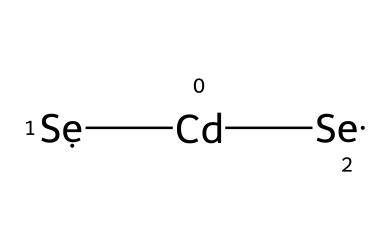What elements are present in this quantum dot? The chemical structure features Cadmium (Cd) and Selenium (Se), which can be identified by their symbols in the SMILES representation.
Answer: Cadmium, Selenium How many atoms are in the quantum dot? The SMILES representation indicates there are four atoms: one Cadmium and three Selenium atoms. Count the number of each distinct atom to confirm.
Answer: four What is the molecular formula of this quantum dot? From the SMILES, the composition shows 1 Cadmium and 3 Selenium atoms, leading to the molecular formula being CdSe3.
Answer: CdSe3 What type of bonding is present in this quantum dot? The structure shows that Cadmium and Selenium are likely to form covalent bonds due to proximity and typical bonding behaviors of these elements, confirmed by their usual interactions.
Answer: covalent What is the primary application of these quantum dots in sports injury diagnostics? Quantum dots like these are used for their luminescent properties, allowing for advanced imaging techniques in detecting injuries through improved contrast and visualization.
Answer: imaging Why are quantum dots preferred in diagnostic imaging over traditional methods? Quantum dots offer better stability, tunability in luminescence, and smaller size, providing enhanced resolution and specificity in medical imaging compared to traditional imaging agents.
Answer: stability, tunability, resolution 